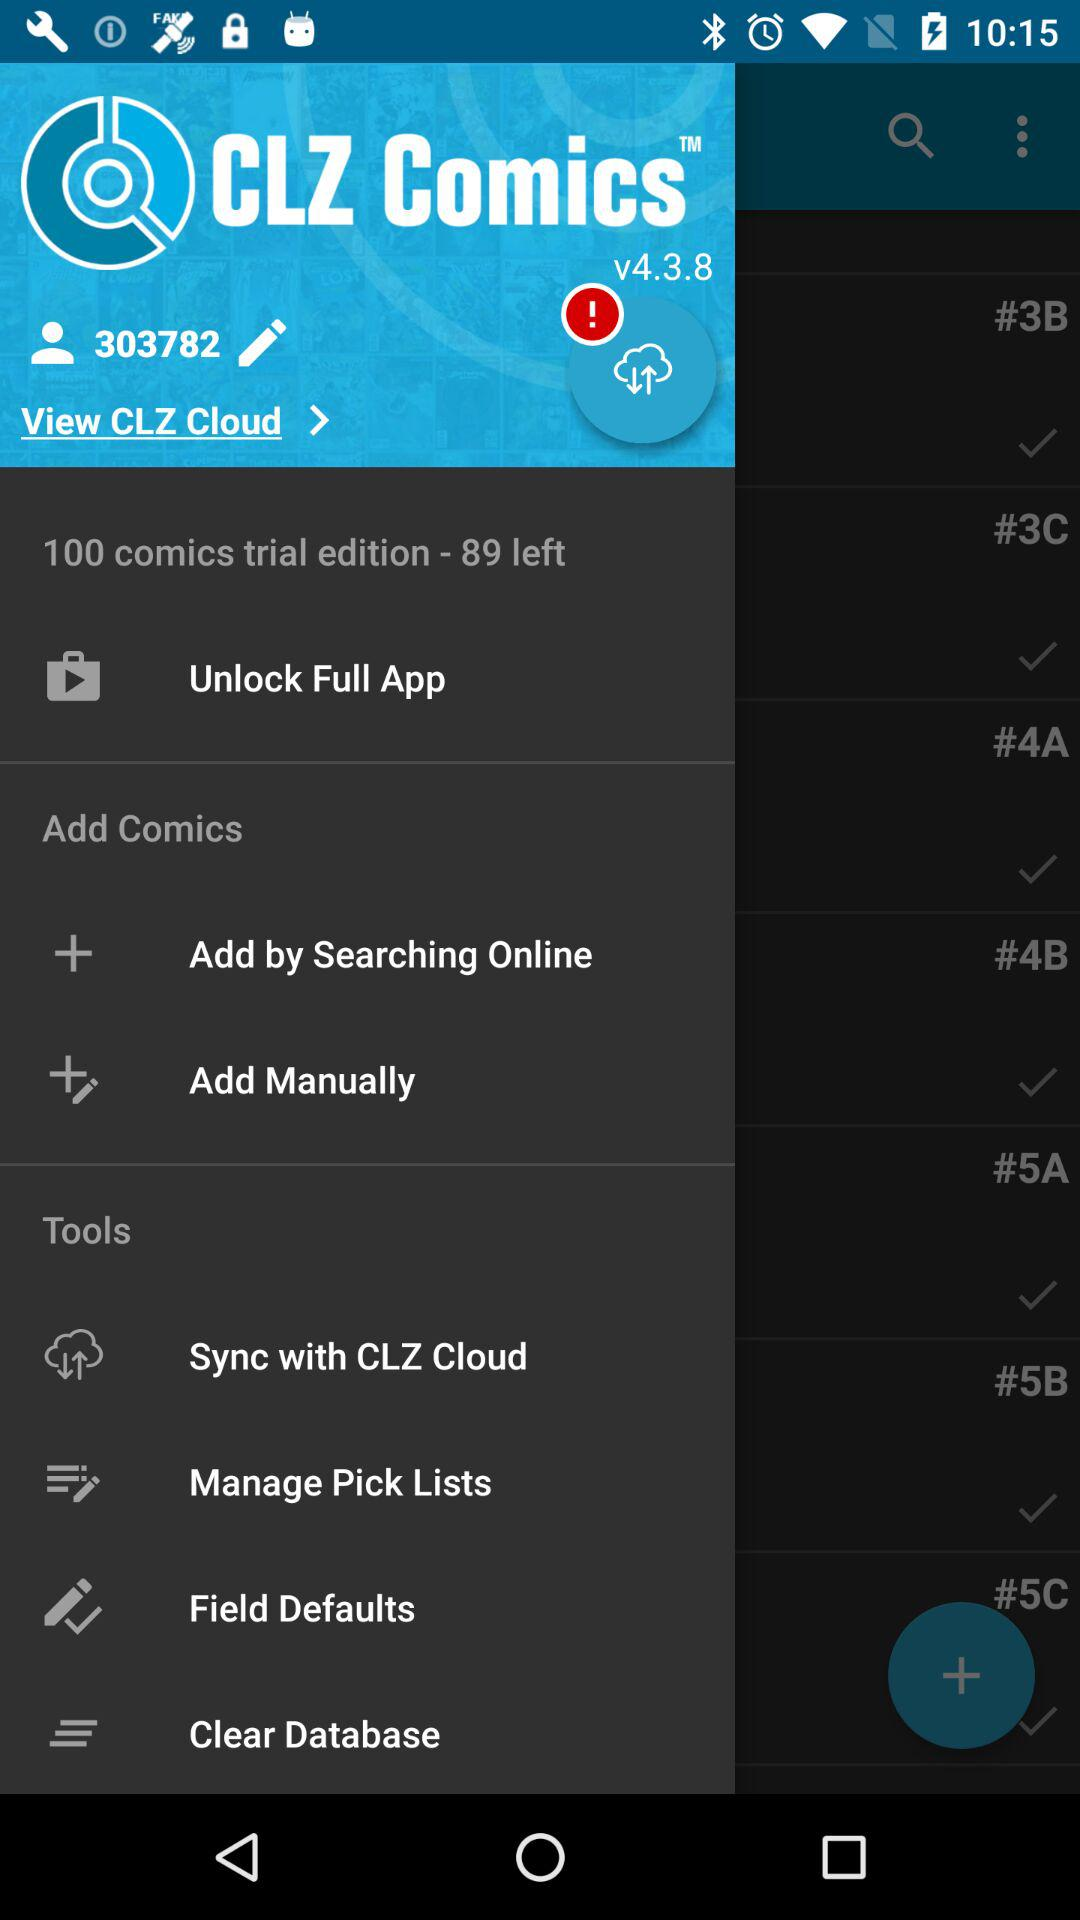How many comics are left for the trial edition out of the total? There are 89 comics left. 